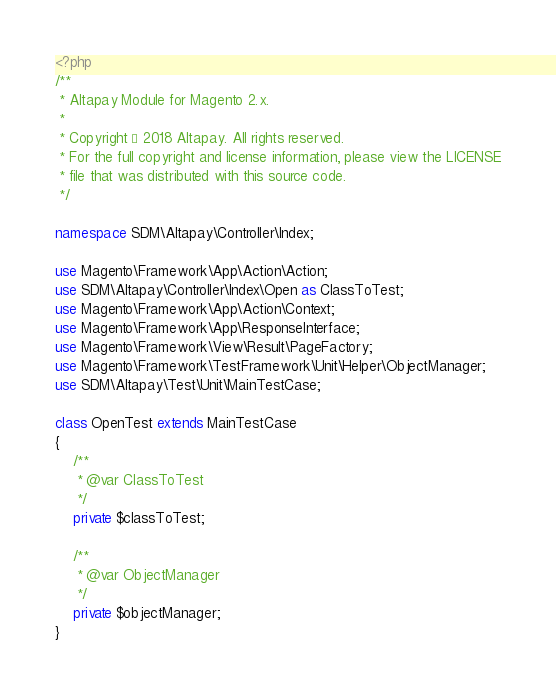<code> <loc_0><loc_0><loc_500><loc_500><_PHP_><?php
/**
 * Altapay Module for Magento 2.x.
 *
 * Copyright © 2018 Altapay. All rights reserved.
 * For the full copyright and license information, please view the LICENSE
 * file that was distributed with this source code.
 */

namespace SDM\Altapay\Controller\Index;

use Magento\Framework\App\Action\Action;
use SDM\Altapay\Controller\Index\Open as ClassToTest;
use Magento\Framework\App\Action\Context;
use Magento\Framework\App\ResponseInterface;
use Magento\Framework\View\Result\PageFactory;
use Magento\Framework\TestFramework\Unit\Helper\ObjectManager;
use SDM\Altapay\Test\Unit\MainTestCase;

class OpenTest extends MainTestCase
{
    /**
     * @var ClassToTest
     */
    private $classToTest;

    /**
     * @var ObjectManager
     */
    private $objectManager;
}
</code> 